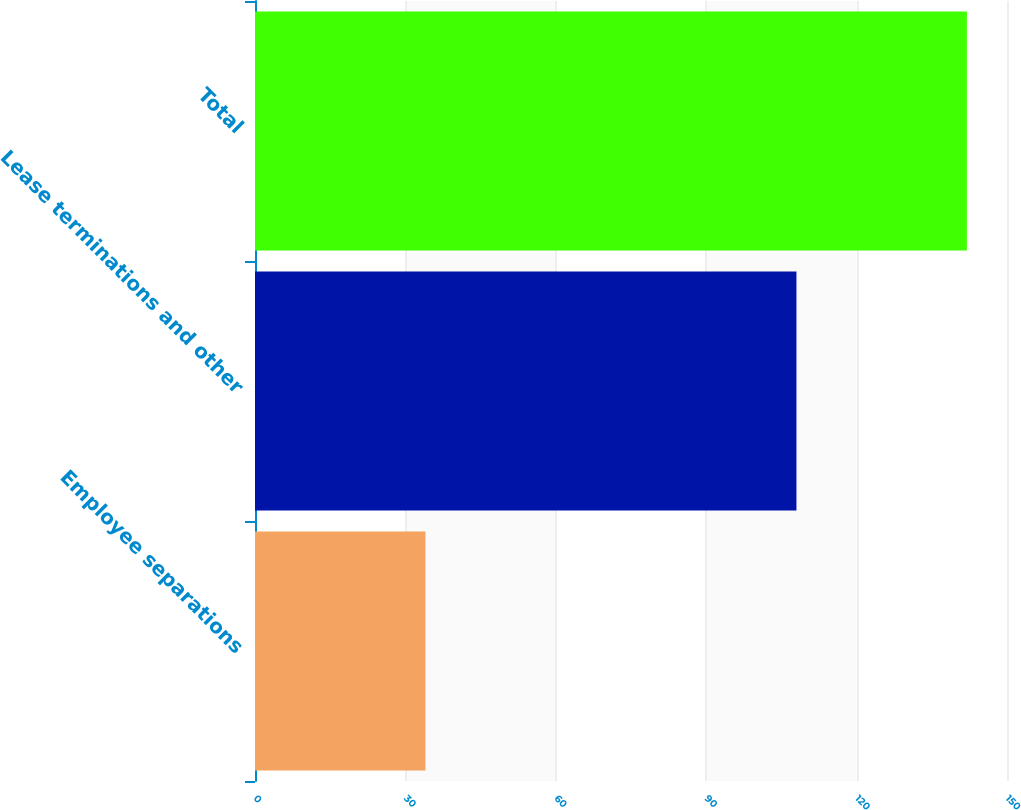Convert chart. <chart><loc_0><loc_0><loc_500><loc_500><bar_chart><fcel>Employee separations<fcel>Lease terminations and other<fcel>Total<nl><fcel>34<fcel>108<fcel>142<nl></chart> 